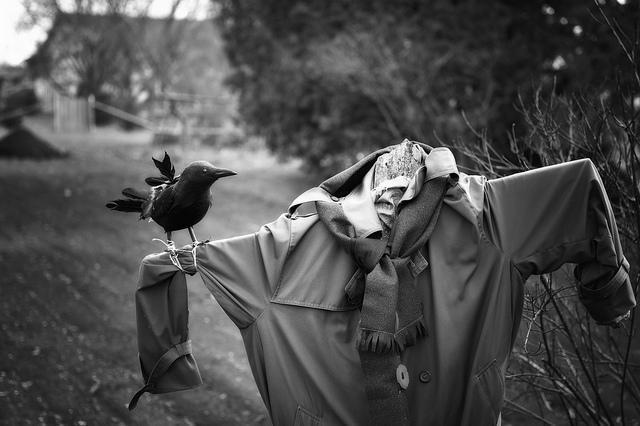How many white buttons are there?
Give a very brief answer. 1. 